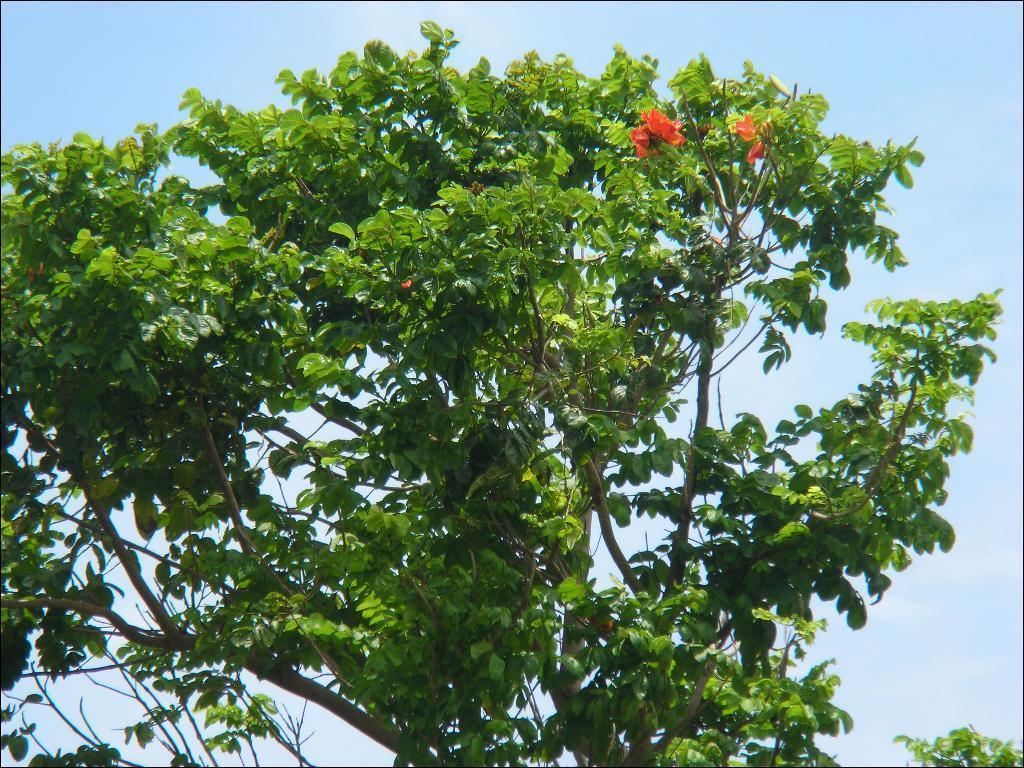Describe this image in one or two sentences. In the picture we can see the part of the tree with many leaves and behind it we can see the sky. 